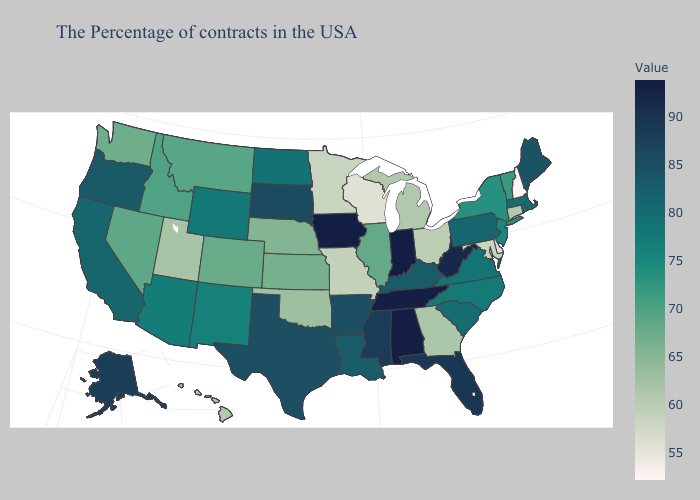Does Wisconsin have the lowest value in the MidWest?
Write a very short answer. Yes. Which states have the lowest value in the USA?
Short answer required. New Hampshire. Does the map have missing data?
Give a very brief answer. No. Does Maryland have the lowest value in the USA?
Answer briefly. No. Among the states that border Kentucky , does Ohio have the lowest value?
Give a very brief answer. No. 